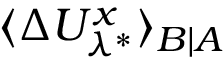Convert formula to latex. <formula><loc_0><loc_0><loc_500><loc_500>\langle \Delta U _ { \lambda ^ { * } } ^ { x } \rangle _ { B | A }</formula> 